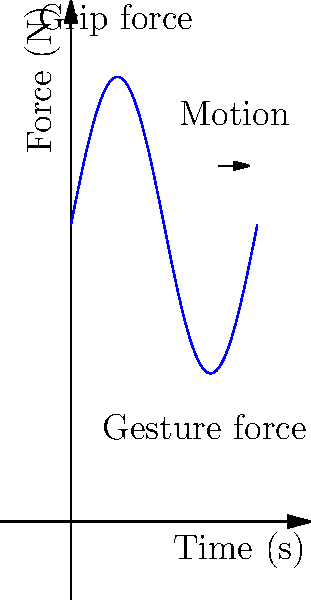As an aspiring rapper, understanding the biomechanics of hand movements during mic gripping and gesturing is crucial for your stage presence. The graph shows the force applied by your hand over time during a typical performance. If the maximum grip force is 15 N and the average gesture force is 10 N, calculate the total work done by your hand muscles over a 6-second performance, assuming a displacement of 0.5 m for both gripping and gesturing motions. Let's break this down step-by-step:

1. Identify the forces:
   - Maximum grip force = 15 N
   - Average gesture force = 10 N

2. Identify the displacement:
   - Both gripping and gesturing have a displacement of 0.5 m

3. Calculate the work done by gripping:
   $W_{grip} = F_{grip} \times d_{grip}$
   $W_{grip} = 15 \text{ N} \times 0.5 \text{ m} = 7.5 \text{ J}$

4. Calculate the work done by gesturing:
   $W_{gesture} = F_{gesture} \times d_{gesture}$
   $W_{gesture} = 10 \text{ N} \times 0.5 \text{ m} = 5 \text{ J}$

5. Sum up the total work:
   $W_{total} = W_{grip} + W_{gesture}$
   $W_{total} = 7.5 \text{ J} + 5 \text{ J} = 12.5 \text{ J}$

The total work done by your hand muscles over the 6-second performance is 12.5 J.
Answer: 12.5 J 